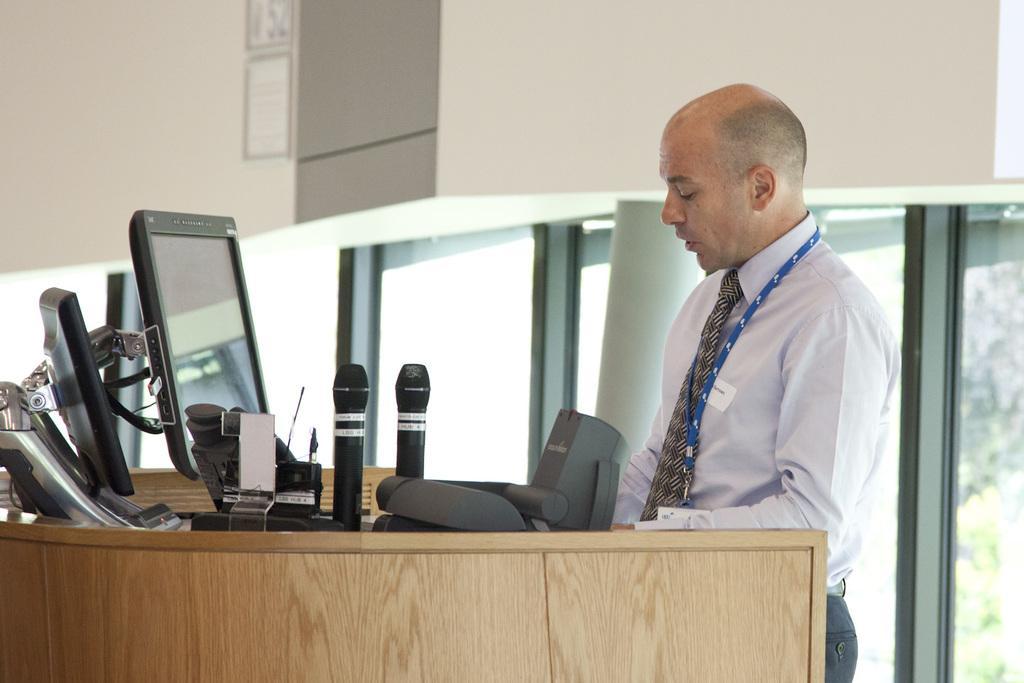In one or two sentences, can you explain what this image depicts? In this image there is a person wearing white shirt is standing before a table having few monitors, mikes and few objects on it. He is wearing tie. Behind him there are few windows to the wall. 